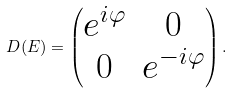<formula> <loc_0><loc_0><loc_500><loc_500>D ( E ) = \begin{pmatrix} e ^ { i \varphi } & 0 \\ 0 & e ^ { - i \varphi } \end{pmatrix} .</formula> 